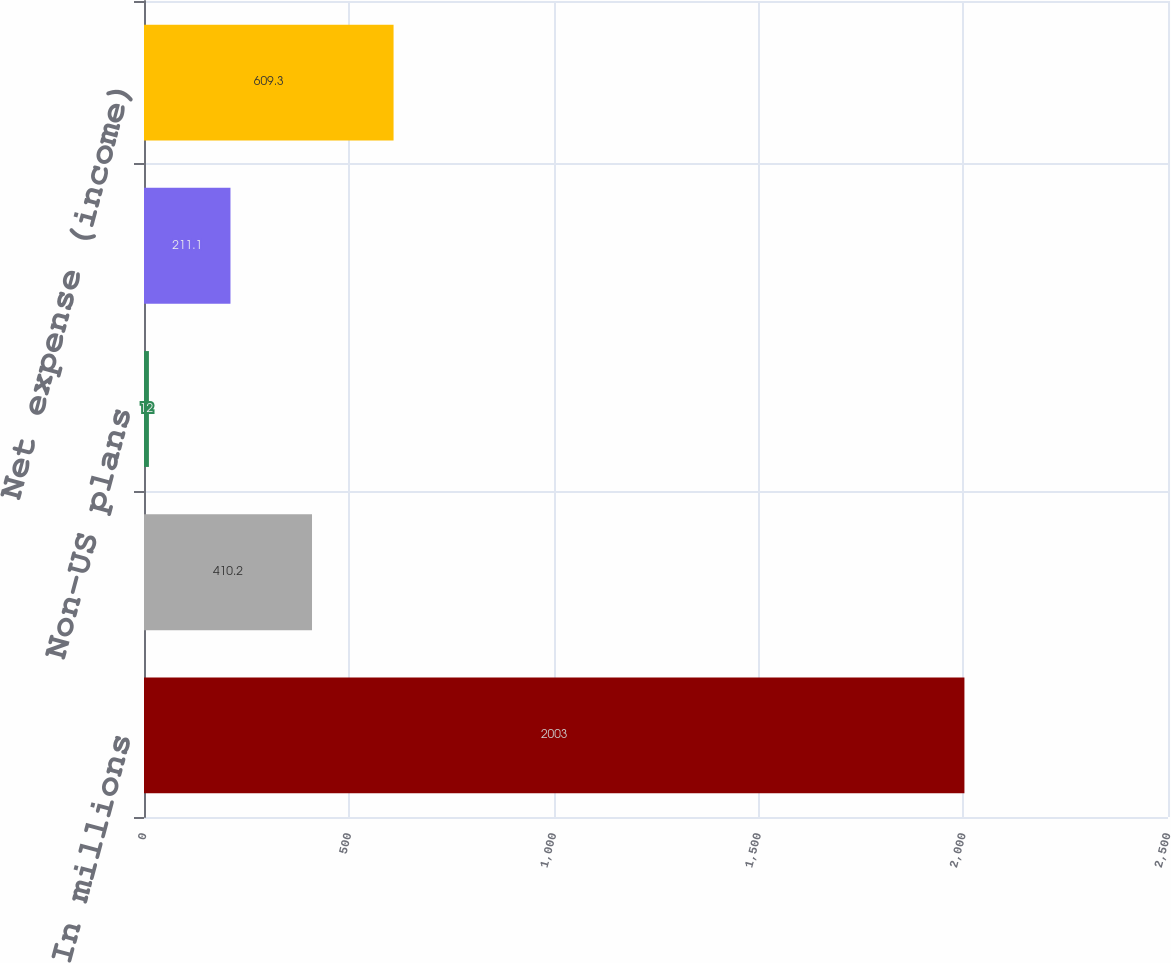Convert chart to OTSL. <chart><loc_0><loc_0><loc_500><loc_500><bar_chart><fcel>In millions<fcel>US plans (non-cash)<fcel>Non-US plans<fcel>US plans<fcel>Net expense (income)<nl><fcel>2003<fcel>410.2<fcel>12<fcel>211.1<fcel>609.3<nl></chart> 